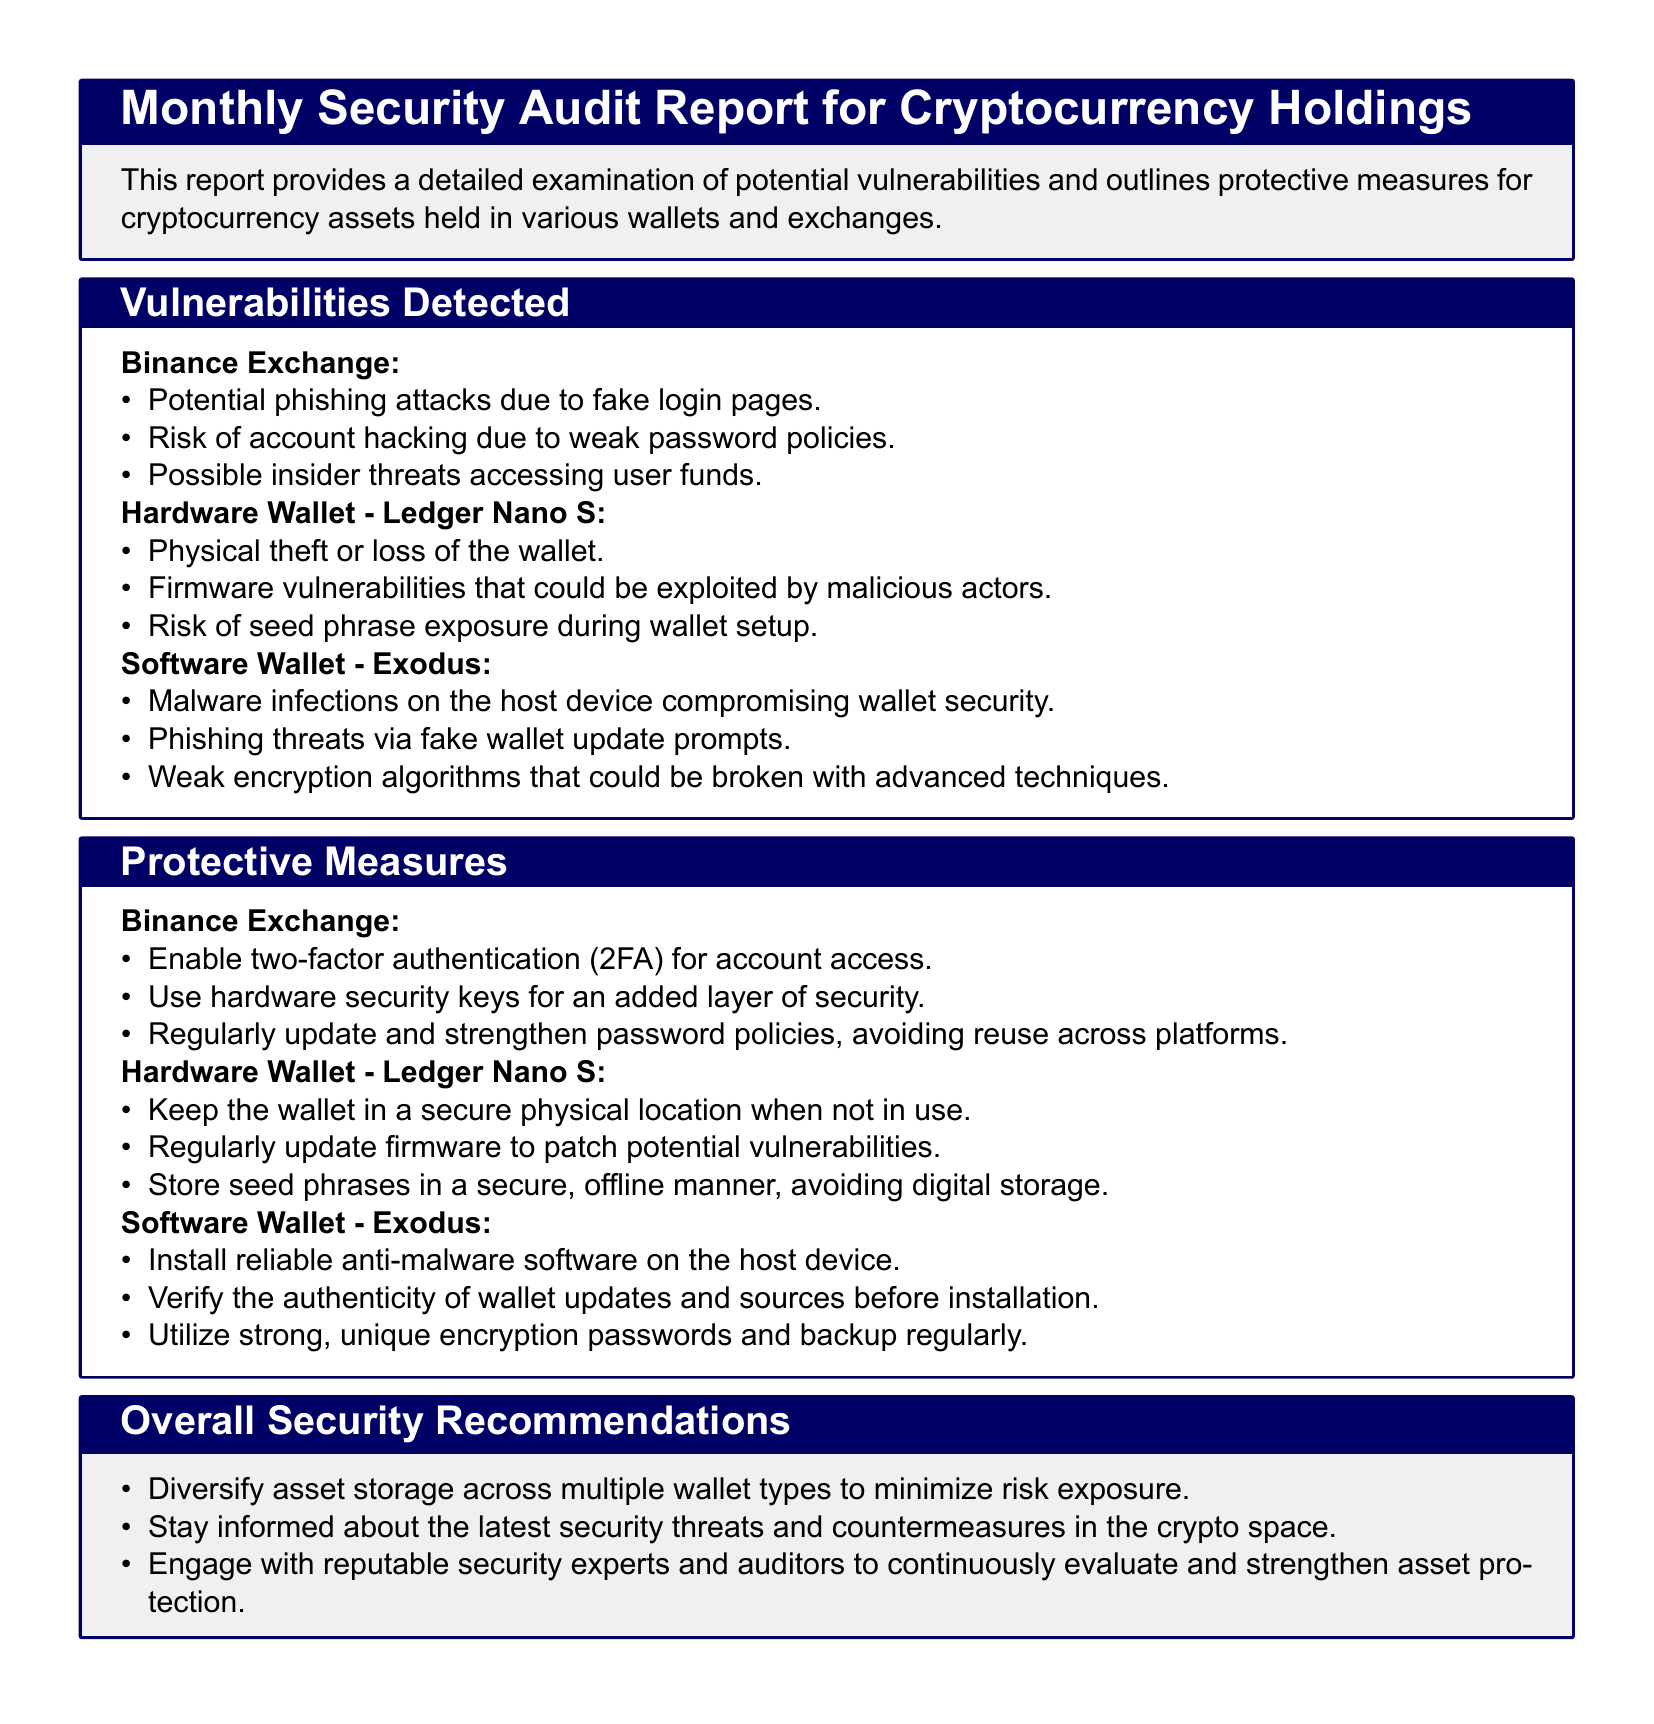what is the first vulnerability detected in Binance Exchange? The first vulnerability listed for Binance Exchange in the document is the potential for phishing attacks due to fake login pages.
Answer: potential phishing attacks due to fake login pages how many risks are identified for the Hardware Wallet - Ledger Nano S? The risks identified for the Ledger Nano S are three, as detailed in the document.
Answer: three what protective measure is recommended for Binance Exchange? The document recommends enabling two-factor authentication for account access as a protective measure for Binance Exchange.
Answer: enable two-factor authentication (2FA) for account access what is the risk associated with the software wallet Exodus? One of the risks associated with the Exodus wallet is malware infections on the host device compromising wallet security.
Answer: malware infections on the host device compromising wallet security what action is suggested regarding seed phrases for the Ledger Nano S? The document suggests storing seed phrases in a secure, offline manner, avoiding digital storage.
Answer: store seed phrases in a secure, offline manner how many overall security recommendations are listed in the report? The report lists three overall security recommendations for asset protection.
Answer: three what should users do to verify wallet updates for the Exodus wallet? Users should verify the authenticity of wallet updates and sources before installation, according to the document.
Answer: verify the authenticity of wallet updates and sources which wallet is identified as a hardware wallet in the document? The Ledger Nano S is identified as the hardware wallet in the document.
Answer: Ledger Nano S 